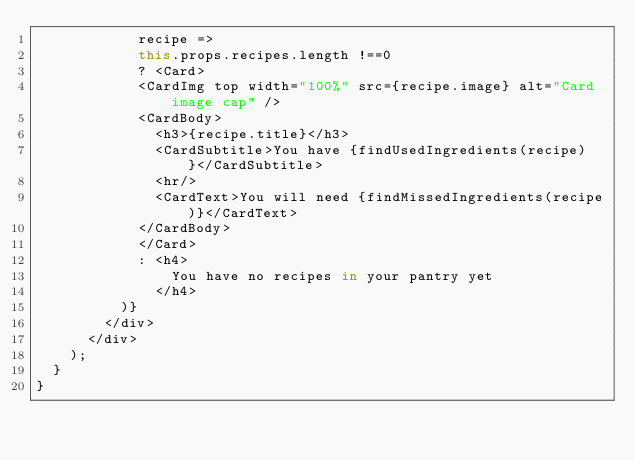<code> <loc_0><loc_0><loc_500><loc_500><_JavaScript_>            recipe =>
            this.props.recipes.length !==0
            ? <Card>
            <CardImg top width="100%" src={recipe.image} alt="Card image cap" />
            <CardBody>
              <h3>{recipe.title}</h3>
              <CardSubtitle>You have {findUsedIngredients(recipe)}</CardSubtitle>
              <hr/>
              <CardText>You will need {findMissedIngredients(recipe)}</CardText>
            </CardBody>
            </Card>
            : <h4>
                You have no recipes in your pantry yet
              </h4>
          )}
        </div>
      </div>
    );
  }
}

</code> 